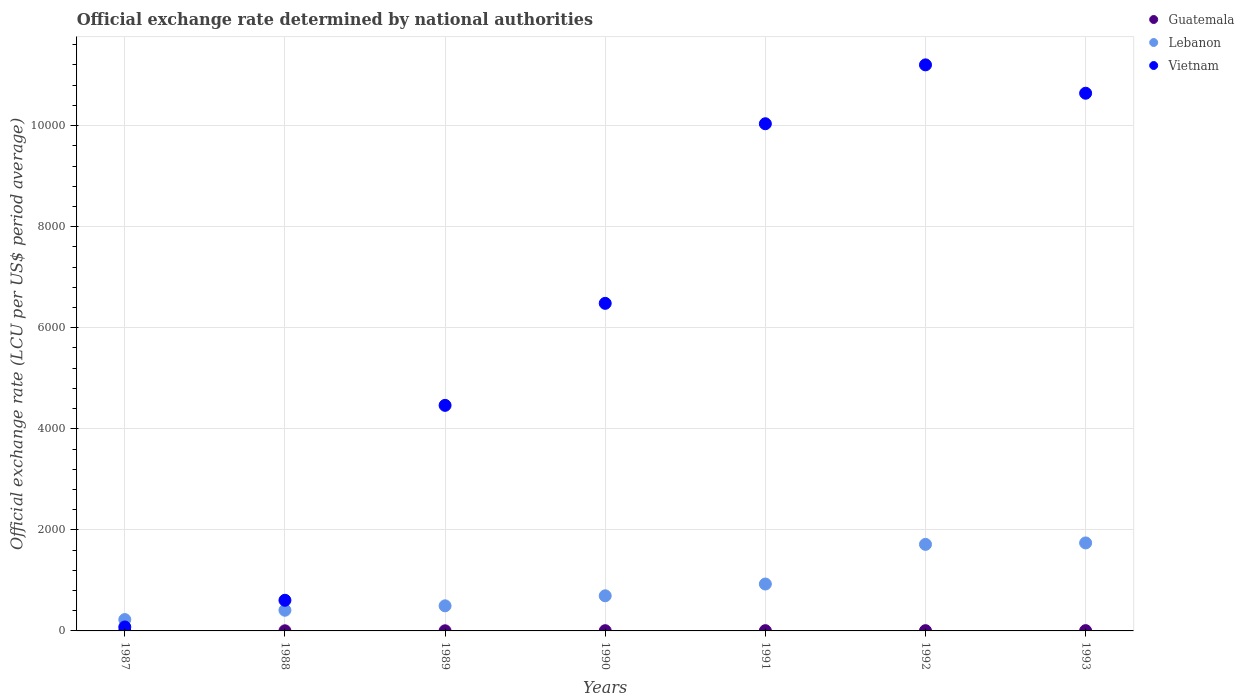How many different coloured dotlines are there?
Your response must be concise. 3. Is the number of dotlines equal to the number of legend labels?
Your answer should be compact. Yes. What is the official exchange rate in Guatemala in 1988?
Your response must be concise. 2.62. Across all years, what is the maximum official exchange rate in Guatemala?
Offer a terse response. 5.64. Across all years, what is the minimum official exchange rate in Guatemala?
Offer a terse response. 2.5. In which year was the official exchange rate in Lebanon maximum?
Your answer should be very brief. 1993. In which year was the official exchange rate in Lebanon minimum?
Ensure brevity in your answer.  1987. What is the total official exchange rate in Guatemala in the graph?
Provide a short and direct response. 28.26. What is the difference between the official exchange rate in Lebanon in 1988 and that in 1990?
Provide a succinct answer. -285.86. What is the difference between the official exchange rate in Vietnam in 1991 and the official exchange rate in Guatemala in 1989?
Keep it short and to the point. 1.00e+04. What is the average official exchange rate in Lebanon per year?
Give a very brief answer. 886.86. In the year 1988, what is the difference between the official exchange rate in Vietnam and official exchange rate in Guatemala?
Provide a short and direct response. 603.9. What is the ratio of the official exchange rate in Vietnam in 1987 to that in 1991?
Your answer should be compact. 0.01. Is the difference between the official exchange rate in Vietnam in 1988 and 1990 greater than the difference between the official exchange rate in Guatemala in 1988 and 1990?
Offer a terse response. No. What is the difference between the highest and the second highest official exchange rate in Vietnam?
Your response must be concise. 561.23. What is the difference between the highest and the lowest official exchange rate in Lebanon?
Give a very brief answer. 1516.77. In how many years, is the official exchange rate in Vietnam greater than the average official exchange rate in Vietnam taken over all years?
Offer a very short reply. 4. Does the official exchange rate in Lebanon monotonically increase over the years?
Provide a short and direct response. Yes. Is the official exchange rate in Vietnam strictly greater than the official exchange rate in Lebanon over the years?
Make the answer very short. No. Is the official exchange rate in Lebanon strictly less than the official exchange rate in Vietnam over the years?
Provide a succinct answer. No. How many dotlines are there?
Keep it short and to the point. 3. How many years are there in the graph?
Ensure brevity in your answer.  7. What is the difference between two consecutive major ticks on the Y-axis?
Offer a very short reply. 2000. Does the graph contain grids?
Give a very brief answer. Yes. Where does the legend appear in the graph?
Provide a short and direct response. Top right. How many legend labels are there?
Your response must be concise. 3. What is the title of the graph?
Your answer should be very brief. Official exchange rate determined by national authorities. Does "Uzbekistan" appear as one of the legend labels in the graph?
Your response must be concise. No. What is the label or title of the Y-axis?
Your answer should be compact. Official exchange rate (LCU per US$ period average). What is the Official exchange rate (LCU per US$ period average) in Guatemala in 1987?
Ensure brevity in your answer.  2.5. What is the Official exchange rate (LCU per US$ period average) in Lebanon in 1987?
Offer a very short reply. 224.6. What is the Official exchange rate (LCU per US$ period average) of Vietnam in 1987?
Keep it short and to the point. 78.29. What is the Official exchange rate (LCU per US$ period average) of Guatemala in 1988?
Your answer should be very brief. 2.62. What is the Official exchange rate (LCU per US$ period average) in Lebanon in 1988?
Give a very brief answer. 409.23. What is the Official exchange rate (LCU per US$ period average) of Vietnam in 1988?
Keep it short and to the point. 606.52. What is the Official exchange rate (LCU per US$ period average) of Guatemala in 1989?
Give a very brief answer. 2.82. What is the Official exchange rate (LCU per US$ period average) of Lebanon in 1989?
Your answer should be compact. 496.69. What is the Official exchange rate (LCU per US$ period average) in Vietnam in 1989?
Ensure brevity in your answer.  4463.95. What is the Official exchange rate (LCU per US$ period average) of Guatemala in 1990?
Your response must be concise. 4.49. What is the Official exchange rate (LCU per US$ period average) in Lebanon in 1990?
Your response must be concise. 695.09. What is the Official exchange rate (LCU per US$ period average) in Vietnam in 1990?
Ensure brevity in your answer.  6482.8. What is the Official exchange rate (LCU per US$ period average) of Guatemala in 1991?
Your response must be concise. 5.03. What is the Official exchange rate (LCU per US$ period average) of Lebanon in 1991?
Your answer should be very brief. 928.23. What is the Official exchange rate (LCU per US$ period average) in Vietnam in 1991?
Provide a succinct answer. 1.00e+04. What is the Official exchange rate (LCU per US$ period average) of Guatemala in 1992?
Provide a short and direct response. 5.17. What is the Official exchange rate (LCU per US$ period average) in Lebanon in 1992?
Offer a terse response. 1712.79. What is the Official exchange rate (LCU per US$ period average) in Vietnam in 1992?
Keep it short and to the point. 1.12e+04. What is the Official exchange rate (LCU per US$ period average) in Guatemala in 1993?
Offer a very short reply. 5.64. What is the Official exchange rate (LCU per US$ period average) of Lebanon in 1993?
Ensure brevity in your answer.  1741.36. What is the Official exchange rate (LCU per US$ period average) of Vietnam in 1993?
Make the answer very short. 1.06e+04. Across all years, what is the maximum Official exchange rate (LCU per US$ period average) in Guatemala?
Your answer should be compact. 5.64. Across all years, what is the maximum Official exchange rate (LCU per US$ period average) in Lebanon?
Offer a very short reply. 1741.36. Across all years, what is the maximum Official exchange rate (LCU per US$ period average) in Vietnam?
Offer a very short reply. 1.12e+04. Across all years, what is the minimum Official exchange rate (LCU per US$ period average) in Guatemala?
Keep it short and to the point. 2.5. Across all years, what is the minimum Official exchange rate (LCU per US$ period average) of Lebanon?
Give a very brief answer. 224.6. Across all years, what is the minimum Official exchange rate (LCU per US$ period average) of Vietnam?
Ensure brevity in your answer.  78.29. What is the total Official exchange rate (LCU per US$ period average) of Guatemala in the graph?
Offer a terse response. 28.26. What is the total Official exchange rate (LCU per US$ period average) in Lebanon in the graph?
Your answer should be compact. 6207.99. What is the total Official exchange rate (LCU per US$ period average) in Vietnam in the graph?
Keep it short and to the point. 4.35e+04. What is the difference between the Official exchange rate (LCU per US$ period average) in Guatemala in 1987 and that in 1988?
Your response must be concise. -0.12. What is the difference between the Official exchange rate (LCU per US$ period average) of Lebanon in 1987 and that in 1988?
Provide a succinct answer. -184.63. What is the difference between the Official exchange rate (LCU per US$ period average) in Vietnam in 1987 and that in 1988?
Provide a succinct answer. -528.23. What is the difference between the Official exchange rate (LCU per US$ period average) in Guatemala in 1987 and that in 1989?
Provide a succinct answer. -0.32. What is the difference between the Official exchange rate (LCU per US$ period average) in Lebanon in 1987 and that in 1989?
Offer a very short reply. -272.09. What is the difference between the Official exchange rate (LCU per US$ period average) in Vietnam in 1987 and that in 1989?
Your response must be concise. -4385.65. What is the difference between the Official exchange rate (LCU per US$ period average) in Guatemala in 1987 and that in 1990?
Provide a short and direct response. -1.99. What is the difference between the Official exchange rate (LCU per US$ period average) of Lebanon in 1987 and that in 1990?
Offer a very short reply. -470.49. What is the difference between the Official exchange rate (LCU per US$ period average) of Vietnam in 1987 and that in 1990?
Make the answer very short. -6404.5. What is the difference between the Official exchange rate (LCU per US$ period average) in Guatemala in 1987 and that in 1991?
Your answer should be compact. -2.53. What is the difference between the Official exchange rate (LCU per US$ period average) of Lebanon in 1987 and that in 1991?
Your response must be concise. -703.63. What is the difference between the Official exchange rate (LCU per US$ period average) of Vietnam in 1987 and that in 1991?
Ensure brevity in your answer.  -9958.74. What is the difference between the Official exchange rate (LCU per US$ period average) of Guatemala in 1987 and that in 1992?
Give a very brief answer. -2.67. What is the difference between the Official exchange rate (LCU per US$ period average) in Lebanon in 1987 and that in 1992?
Your answer should be compact. -1488.19. What is the difference between the Official exchange rate (LCU per US$ period average) of Vietnam in 1987 and that in 1992?
Provide a short and direct response. -1.11e+04. What is the difference between the Official exchange rate (LCU per US$ period average) in Guatemala in 1987 and that in 1993?
Give a very brief answer. -3.14. What is the difference between the Official exchange rate (LCU per US$ period average) in Lebanon in 1987 and that in 1993?
Your answer should be compact. -1516.77. What is the difference between the Official exchange rate (LCU per US$ period average) in Vietnam in 1987 and that in 1993?
Your answer should be compact. -1.06e+04. What is the difference between the Official exchange rate (LCU per US$ period average) of Guatemala in 1988 and that in 1989?
Ensure brevity in your answer.  -0.2. What is the difference between the Official exchange rate (LCU per US$ period average) in Lebanon in 1988 and that in 1989?
Keep it short and to the point. -87.46. What is the difference between the Official exchange rate (LCU per US$ period average) in Vietnam in 1988 and that in 1989?
Provide a short and direct response. -3857.43. What is the difference between the Official exchange rate (LCU per US$ period average) in Guatemala in 1988 and that in 1990?
Your answer should be very brief. -1.87. What is the difference between the Official exchange rate (LCU per US$ period average) of Lebanon in 1988 and that in 1990?
Give a very brief answer. -285.86. What is the difference between the Official exchange rate (LCU per US$ period average) of Vietnam in 1988 and that in 1990?
Make the answer very short. -5876.28. What is the difference between the Official exchange rate (LCU per US$ period average) of Guatemala in 1988 and that in 1991?
Keep it short and to the point. -2.41. What is the difference between the Official exchange rate (LCU per US$ period average) in Lebanon in 1988 and that in 1991?
Offer a terse response. -519. What is the difference between the Official exchange rate (LCU per US$ period average) in Vietnam in 1988 and that in 1991?
Provide a succinct answer. -9430.52. What is the difference between the Official exchange rate (LCU per US$ period average) in Guatemala in 1988 and that in 1992?
Your answer should be very brief. -2.55. What is the difference between the Official exchange rate (LCU per US$ period average) in Lebanon in 1988 and that in 1992?
Provide a succinct answer. -1303.56. What is the difference between the Official exchange rate (LCU per US$ period average) in Vietnam in 1988 and that in 1992?
Ensure brevity in your answer.  -1.06e+04. What is the difference between the Official exchange rate (LCU per US$ period average) of Guatemala in 1988 and that in 1993?
Offer a very short reply. -3.02. What is the difference between the Official exchange rate (LCU per US$ period average) in Lebanon in 1988 and that in 1993?
Provide a succinct answer. -1332.13. What is the difference between the Official exchange rate (LCU per US$ period average) in Vietnam in 1988 and that in 1993?
Your answer should be very brief. -1.00e+04. What is the difference between the Official exchange rate (LCU per US$ period average) of Guatemala in 1989 and that in 1990?
Offer a very short reply. -1.67. What is the difference between the Official exchange rate (LCU per US$ period average) of Lebanon in 1989 and that in 1990?
Provide a short and direct response. -198.4. What is the difference between the Official exchange rate (LCU per US$ period average) of Vietnam in 1989 and that in 1990?
Your answer should be very brief. -2018.85. What is the difference between the Official exchange rate (LCU per US$ period average) in Guatemala in 1989 and that in 1991?
Keep it short and to the point. -2.21. What is the difference between the Official exchange rate (LCU per US$ period average) of Lebanon in 1989 and that in 1991?
Give a very brief answer. -431.54. What is the difference between the Official exchange rate (LCU per US$ period average) in Vietnam in 1989 and that in 1991?
Ensure brevity in your answer.  -5573.09. What is the difference between the Official exchange rate (LCU per US$ period average) of Guatemala in 1989 and that in 1992?
Ensure brevity in your answer.  -2.35. What is the difference between the Official exchange rate (LCU per US$ period average) of Lebanon in 1989 and that in 1992?
Your response must be concise. -1216.1. What is the difference between the Official exchange rate (LCU per US$ period average) of Vietnam in 1989 and that in 1992?
Keep it short and to the point. -6738.25. What is the difference between the Official exchange rate (LCU per US$ period average) of Guatemala in 1989 and that in 1993?
Keep it short and to the point. -2.82. What is the difference between the Official exchange rate (LCU per US$ period average) in Lebanon in 1989 and that in 1993?
Your response must be concise. -1244.67. What is the difference between the Official exchange rate (LCU per US$ period average) of Vietnam in 1989 and that in 1993?
Keep it short and to the point. -6177.01. What is the difference between the Official exchange rate (LCU per US$ period average) in Guatemala in 1990 and that in 1991?
Give a very brief answer. -0.54. What is the difference between the Official exchange rate (LCU per US$ period average) of Lebanon in 1990 and that in 1991?
Offer a very short reply. -233.14. What is the difference between the Official exchange rate (LCU per US$ period average) of Vietnam in 1990 and that in 1991?
Offer a terse response. -3554.24. What is the difference between the Official exchange rate (LCU per US$ period average) of Guatemala in 1990 and that in 1992?
Provide a short and direct response. -0.68. What is the difference between the Official exchange rate (LCU per US$ period average) of Lebanon in 1990 and that in 1992?
Provide a succinct answer. -1017.7. What is the difference between the Official exchange rate (LCU per US$ period average) of Vietnam in 1990 and that in 1992?
Your answer should be compact. -4719.4. What is the difference between the Official exchange rate (LCU per US$ period average) of Guatemala in 1990 and that in 1993?
Ensure brevity in your answer.  -1.15. What is the difference between the Official exchange rate (LCU per US$ period average) of Lebanon in 1990 and that in 1993?
Provide a short and direct response. -1046.27. What is the difference between the Official exchange rate (LCU per US$ period average) of Vietnam in 1990 and that in 1993?
Offer a terse response. -4158.16. What is the difference between the Official exchange rate (LCU per US$ period average) of Guatemala in 1991 and that in 1992?
Give a very brief answer. -0.14. What is the difference between the Official exchange rate (LCU per US$ period average) of Lebanon in 1991 and that in 1992?
Your response must be concise. -784.56. What is the difference between the Official exchange rate (LCU per US$ period average) of Vietnam in 1991 and that in 1992?
Your answer should be very brief. -1165.16. What is the difference between the Official exchange rate (LCU per US$ period average) in Guatemala in 1991 and that in 1993?
Your answer should be very brief. -0.61. What is the difference between the Official exchange rate (LCU per US$ period average) of Lebanon in 1991 and that in 1993?
Offer a very short reply. -813.14. What is the difference between the Official exchange rate (LCU per US$ period average) of Vietnam in 1991 and that in 1993?
Ensure brevity in your answer.  -603.92. What is the difference between the Official exchange rate (LCU per US$ period average) in Guatemala in 1992 and that in 1993?
Make the answer very short. -0.46. What is the difference between the Official exchange rate (LCU per US$ period average) in Lebanon in 1992 and that in 1993?
Your answer should be compact. -28.57. What is the difference between the Official exchange rate (LCU per US$ period average) of Vietnam in 1992 and that in 1993?
Offer a terse response. 561.23. What is the difference between the Official exchange rate (LCU per US$ period average) of Guatemala in 1987 and the Official exchange rate (LCU per US$ period average) of Lebanon in 1988?
Give a very brief answer. -406.73. What is the difference between the Official exchange rate (LCU per US$ period average) in Guatemala in 1987 and the Official exchange rate (LCU per US$ period average) in Vietnam in 1988?
Keep it short and to the point. -604.02. What is the difference between the Official exchange rate (LCU per US$ period average) of Lebanon in 1987 and the Official exchange rate (LCU per US$ period average) of Vietnam in 1988?
Your answer should be compact. -381.92. What is the difference between the Official exchange rate (LCU per US$ period average) in Guatemala in 1987 and the Official exchange rate (LCU per US$ period average) in Lebanon in 1989?
Your answer should be compact. -494.19. What is the difference between the Official exchange rate (LCU per US$ period average) in Guatemala in 1987 and the Official exchange rate (LCU per US$ period average) in Vietnam in 1989?
Give a very brief answer. -4461.45. What is the difference between the Official exchange rate (LCU per US$ period average) of Lebanon in 1987 and the Official exchange rate (LCU per US$ period average) of Vietnam in 1989?
Provide a succinct answer. -4239.35. What is the difference between the Official exchange rate (LCU per US$ period average) of Guatemala in 1987 and the Official exchange rate (LCU per US$ period average) of Lebanon in 1990?
Your answer should be very brief. -692.59. What is the difference between the Official exchange rate (LCU per US$ period average) of Guatemala in 1987 and the Official exchange rate (LCU per US$ period average) of Vietnam in 1990?
Make the answer very short. -6480.3. What is the difference between the Official exchange rate (LCU per US$ period average) in Lebanon in 1987 and the Official exchange rate (LCU per US$ period average) in Vietnam in 1990?
Ensure brevity in your answer.  -6258.2. What is the difference between the Official exchange rate (LCU per US$ period average) in Guatemala in 1987 and the Official exchange rate (LCU per US$ period average) in Lebanon in 1991?
Give a very brief answer. -925.73. What is the difference between the Official exchange rate (LCU per US$ period average) of Guatemala in 1987 and the Official exchange rate (LCU per US$ period average) of Vietnam in 1991?
Your answer should be very brief. -1.00e+04. What is the difference between the Official exchange rate (LCU per US$ period average) of Lebanon in 1987 and the Official exchange rate (LCU per US$ period average) of Vietnam in 1991?
Keep it short and to the point. -9812.44. What is the difference between the Official exchange rate (LCU per US$ period average) in Guatemala in 1987 and the Official exchange rate (LCU per US$ period average) in Lebanon in 1992?
Keep it short and to the point. -1710.29. What is the difference between the Official exchange rate (LCU per US$ period average) of Guatemala in 1987 and the Official exchange rate (LCU per US$ period average) of Vietnam in 1992?
Your response must be concise. -1.12e+04. What is the difference between the Official exchange rate (LCU per US$ period average) of Lebanon in 1987 and the Official exchange rate (LCU per US$ period average) of Vietnam in 1992?
Your answer should be compact. -1.10e+04. What is the difference between the Official exchange rate (LCU per US$ period average) in Guatemala in 1987 and the Official exchange rate (LCU per US$ period average) in Lebanon in 1993?
Provide a succinct answer. -1738.86. What is the difference between the Official exchange rate (LCU per US$ period average) of Guatemala in 1987 and the Official exchange rate (LCU per US$ period average) of Vietnam in 1993?
Offer a terse response. -1.06e+04. What is the difference between the Official exchange rate (LCU per US$ period average) in Lebanon in 1987 and the Official exchange rate (LCU per US$ period average) in Vietnam in 1993?
Keep it short and to the point. -1.04e+04. What is the difference between the Official exchange rate (LCU per US$ period average) in Guatemala in 1988 and the Official exchange rate (LCU per US$ period average) in Lebanon in 1989?
Offer a terse response. -494.07. What is the difference between the Official exchange rate (LCU per US$ period average) of Guatemala in 1988 and the Official exchange rate (LCU per US$ period average) of Vietnam in 1989?
Your answer should be very brief. -4461.33. What is the difference between the Official exchange rate (LCU per US$ period average) in Lebanon in 1988 and the Official exchange rate (LCU per US$ period average) in Vietnam in 1989?
Provide a short and direct response. -4054.72. What is the difference between the Official exchange rate (LCU per US$ period average) of Guatemala in 1988 and the Official exchange rate (LCU per US$ period average) of Lebanon in 1990?
Ensure brevity in your answer.  -692.47. What is the difference between the Official exchange rate (LCU per US$ period average) in Guatemala in 1988 and the Official exchange rate (LCU per US$ period average) in Vietnam in 1990?
Offer a very short reply. -6480.18. What is the difference between the Official exchange rate (LCU per US$ period average) in Lebanon in 1988 and the Official exchange rate (LCU per US$ period average) in Vietnam in 1990?
Your answer should be compact. -6073.57. What is the difference between the Official exchange rate (LCU per US$ period average) of Guatemala in 1988 and the Official exchange rate (LCU per US$ period average) of Lebanon in 1991?
Give a very brief answer. -925.61. What is the difference between the Official exchange rate (LCU per US$ period average) of Guatemala in 1988 and the Official exchange rate (LCU per US$ period average) of Vietnam in 1991?
Your answer should be very brief. -1.00e+04. What is the difference between the Official exchange rate (LCU per US$ period average) in Lebanon in 1988 and the Official exchange rate (LCU per US$ period average) in Vietnam in 1991?
Offer a very short reply. -9627.8. What is the difference between the Official exchange rate (LCU per US$ period average) of Guatemala in 1988 and the Official exchange rate (LCU per US$ period average) of Lebanon in 1992?
Your answer should be compact. -1710.17. What is the difference between the Official exchange rate (LCU per US$ period average) of Guatemala in 1988 and the Official exchange rate (LCU per US$ period average) of Vietnam in 1992?
Make the answer very short. -1.12e+04. What is the difference between the Official exchange rate (LCU per US$ period average) of Lebanon in 1988 and the Official exchange rate (LCU per US$ period average) of Vietnam in 1992?
Your answer should be compact. -1.08e+04. What is the difference between the Official exchange rate (LCU per US$ period average) of Guatemala in 1988 and the Official exchange rate (LCU per US$ period average) of Lebanon in 1993?
Ensure brevity in your answer.  -1738.74. What is the difference between the Official exchange rate (LCU per US$ period average) in Guatemala in 1988 and the Official exchange rate (LCU per US$ period average) in Vietnam in 1993?
Keep it short and to the point. -1.06e+04. What is the difference between the Official exchange rate (LCU per US$ period average) in Lebanon in 1988 and the Official exchange rate (LCU per US$ period average) in Vietnam in 1993?
Keep it short and to the point. -1.02e+04. What is the difference between the Official exchange rate (LCU per US$ period average) of Guatemala in 1989 and the Official exchange rate (LCU per US$ period average) of Lebanon in 1990?
Provide a short and direct response. -692.27. What is the difference between the Official exchange rate (LCU per US$ period average) in Guatemala in 1989 and the Official exchange rate (LCU per US$ period average) in Vietnam in 1990?
Ensure brevity in your answer.  -6479.98. What is the difference between the Official exchange rate (LCU per US$ period average) of Lebanon in 1989 and the Official exchange rate (LCU per US$ period average) of Vietnam in 1990?
Your answer should be compact. -5986.11. What is the difference between the Official exchange rate (LCU per US$ period average) in Guatemala in 1989 and the Official exchange rate (LCU per US$ period average) in Lebanon in 1991?
Provide a succinct answer. -925.41. What is the difference between the Official exchange rate (LCU per US$ period average) in Guatemala in 1989 and the Official exchange rate (LCU per US$ period average) in Vietnam in 1991?
Give a very brief answer. -1.00e+04. What is the difference between the Official exchange rate (LCU per US$ period average) of Lebanon in 1989 and the Official exchange rate (LCU per US$ period average) of Vietnam in 1991?
Offer a terse response. -9540.35. What is the difference between the Official exchange rate (LCU per US$ period average) in Guatemala in 1989 and the Official exchange rate (LCU per US$ period average) in Lebanon in 1992?
Your answer should be very brief. -1709.97. What is the difference between the Official exchange rate (LCU per US$ period average) in Guatemala in 1989 and the Official exchange rate (LCU per US$ period average) in Vietnam in 1992?
Offer a terse response. -1.12e+04. What is the difference between the Official exchange rate (LCU per US$ period average) of Lebanon in 1989 and the Official exchange rate (LCU per US$ period average) of Vietnam in 1992?
Your answer should be compact. -1.07e+04. What is the difference between the Official exchange rate (LCU per US$ period average) of Guatemala in 1989 and the Official exchange rate (LCU per US$ period average) of Lebanon in 1993?
Ensure brevity in your answer.  -1738.55. What is the difference between the Official exchange rate (LCU per US$ period average) in Guatemala in 1989 and the Official exchange rate (LCU per US$ period average) in Vietnam in 1993?
Provide a succinct answer. -1.06e+04. What is the difference between the Official exchange rate (LCU per US$ period average) of Lebanon in 1989 and the Official exchange rate (LCU per US$ period average) of Vietnam in 1993?
Your answer should be very brief. -1.01e+04. What is the difference between the Official exchange rate (LCU per US$ period average) of Guatemala in 1990 and the Official exchange rate (LCU per US$ period average) of Lebanon in 1991?
Make the answer very short. -923.74. What is the difference between the Official exchange rate (LCU per US$ period average) of Guatemala in 1990 and the Official exchange rate (LCU per US$ period average) of Vietnam in 1991?
Provide a short and direct response. -1.00e+04. What is the difference between the Official exchange rate (LCU per US$ period average) in Lebanon in 1990 and the Official exchange rate (LCU per US$ period average) in Vietnam in 1991?
Offer a terse response. -9341.95. What is the difference between the Official exchange rate (LCU per US$ period average) in Guatemala in 1990 and the Official exchange rate (LCU per US$ period average) in Lebanon in 1992?
Offer a very short reply. -1708.31. What is the difference between the Official exchange rate (LCU per US$ period average) in Guatemala in 1990 and the Official exchange rate (LCU per US$ period average) in Vietnam in 1992?
Offer a very short reply. -1.12e+04. What is the difference between the Official exchange rate (LCU per US$ period average) of Lebanon in 1990 and the Official exchange rate (LCU per US$ period average) of Vietnam in 1992?
Your response must be concise. -1.05e+04. What is the difference between the Official exchange rate (LCU per US$ period average) in Guatemala in 1990 and the Official exchange rate (LCU per US$ period average) in Lebanon in 1993?
Your answer should be compact. -1736.88. What is the difference between the Official exchange rate (LCU per US$ period average) in Guatemala in 1990 and the Official exchange rate (LCU per US$ period average) in Vietnam in 1993?
Provide a short and direct response. -1.06e+04. What is the difference between the Official exchange rate (LCU per US$ period average) of Lebanon in 1990 and the Official exchange rate (LCU per US$ period average) of Vietnam in 1993?
Your answer should be compact. -9945.87. What is the difference between the Official exchange rate (LCU per US$ period average) of Guatemala in 1991 and the Official exchange rate (LCU per US$ period average) of Lebanon in 1992?
Your answer should be very brief. -1707.76. What is the difference between the Official exchange rate (LCU per US$ period average) in Guatemala in 1991 and the Official exchange rate (LCU per US$ period average) in Vietnam in 1992?
Your answer should be very brief. -1.12e+04. What is the difference between the Official exchange rate (LCU per US$ period average) in Lebanon in 1991 and the Official exchange rate (LCU per US$ period average) in Vietnam in 1992?
Keep it short and to the point. -1.03e+04. What is the difference between the Official exchange rate (LCU per US$ period average) of Guatemala in 1991 and the Official exchange rate (LCU per US$ period average) of Lebanon in 1993?
Offer a very short reply. -1736.33. What is the difference between the Official exchange rate (LCU per US$ period average) of Guatemala in 1991 and the Official exchange rate (LCU per US$ period average) of Vietnam in 1993?
Provide a succinct answer. -1.06e+04. What is the difference between the Official exchange rate (LCU per US$ period average) of Lebanon in 1991 and the Official exchange rate (LCU per US$ period average) of Vietnam in 1993?
Your answer should be compact. -9712.73. What is the difference between the Official exchange rate (LCU per US$ period average) in Guatemala in 1992 and the Official exchange rate (LCU per US$ period average) in Lebanon in 1993?
Offer a terse response. -1736.19. What is the difference between the Official exchange rate (LCU per US$ period average) of Guatemala in 1992 and the Official exchange rate (LCU per US$ period average) of Vietnam in 1993?
Offer a very short reply. -1.06e+04. What is the difference between the Official exchange rate (LCU per US$ period average) in Lebanon in 1992 and the Official exchange rate (LCU per US$ period average) in Vietnam in 1993?
Provide a succinct answer. -8928.17. What is the average Official exchange rate (LCU per US$ period average) in Guatemala per year?
Your answer should be compact. 4.04. What is the average Official exchange rate (LCU per US$ period average) of Lebanon per year?
Your answer should be compact. 886.86. What is the average Official exchange rate (LCU per US$ period average) in Vietnam per year?
Make the answer very short. 6215.96. In the year 1987, what is the difference between the Official exchange rate (LCU per US$ period average) of Guatemala and Official exchange rate (LCU per US$ period average) of Lebanon?
Keep it short and to the point. -222.1. In the year 1987, what is the difference between the Official exchange rate (LCU per US$ period average) of Guatemala and Official exchange rate (LCU per US$ period average) of Vietnam?
Your answer should be very brief. -75.79. In the year 1987, what is the difference between the Official exchange rate (LCU per US$ period average) of Lebanon and Official exchange rate (LCU per US$ period average) of Vietnam?
Provide a short and direct response. 146.3. In the year 1988, what is the difference between the Official exchange rate (LCU per US$ period average) in Guatemala and Official exchange rate (LCU per US$ period average) in Lebanon?
Your answer should be very brief. -406.61. In the year 1988, what is the difference between the Official exchange rate (LCU per US$ period average) in Guatemala and Official exchange rate (LCU per US$ period average) in Vietnam?
Keep it short and to the point. -603.9. In the year 1988, what is the difference between the Official exchange rate (LCU per US$ period average) of Lebanon and Official exchange rate (LCU per US$ period average) of Vietnam?
Your answer should be compact. -197.29. In the year 1989, what is the difference between the Official exchange rate (LCU per US$ period average) of Guatemala and Official exchange rate (LCU per US$ period average) of Lebanon?
Keep it short and to the point. -493.87. In the year 1989, what is the difference between the Official exchange rate (LCU per US$ period average) of Guatemala and Official exchange rate (LCU per US$ period average) of Vietnam?
Make the answer very short. -4461.13. In the year 1989, what is the difference between the Official exchange rate (LCU per US$ period average) in Lebanon and Official exchange rate (LCU per US$ period average) in Vietnam?
Make the answer very short. -3967.26. In the year 1990, what is the difference between the Official exchange rate (LCU per US$ period average) in Guatemala and Official exchange rate (LCU per US$ period average) in Lebanon?
Ensure brevity in your answer.  -690.6. In the year 1990, what is the difference between the Official exchange rate (LCU per US$ period average) of Guatemala and Official exchange rate (LCU per US$ period average) of Vietnam?
Ensure brevity in your answer.  -6478.31. In the year 1990, what is the difference between the Official exchange rate (LCU per US$ period average) in Lebanon and Official exchange rate (LCU per US$ period average) in Vietnam?
Keep it short and to the point. -5787.71. In the year 1991, what is the difference between the Official exchange rate (LCU per US$ period average) of Guatemala and Official exchange rate (LCU per US$ period average) of Lebanon?
Offer a very short reply. -923.2. In the year 1991, what is the difference between the Official exchange rate (LCU per US$ period average) in Guatemala and Official exchange rate (LCU per US$ period average) in Vietnam?
Offer a very short reply. -1.00e+04. In the year 1991, what is the difference between the Official exchange rate (LCU per US$ period average) of Lebanon and Official exchange rate (LCU per US$ period average) of Vietnam?
Provide a succinct answer. -9108.81. In the year 1992, what is the difference between the Official exchange rate (LCU per US$ period average) in Guatemala and Official exchange rate (LCU per US$ period average) in Lebanon?
Ensure brevity in your answer.  -1707.62. In the year 1992, what is the difference between the Official exchange rate (LCU per US$ period average) of Guatemala and Official exchange rate (LCU per US$ period average) of Vietnam?
Your answer should be very brief. -1.12e+04. In the year 1992, what is the difference between the Official exchange rate (LCU per US$ period average) in Lebanon and Official exchange rate (LCU per US$ period average) in Vietnam?
Provide a succinct answer. -9489.4. In the year 1993, what is the difference between the Official exchange rate (LCU per US$ period average) in Guatemala and Official exchange rate (LCU per US$ period average) in Lebanon?
Your response must be concise. -1735.73. In the year 1993, what is the difference between the Official exchange rate (LCU per US$ period average) in Guatemala and Official exchange rate (LCU per US$ period average) in Vietnam?
Your answer should be compact. -1.06e+04. In the year 1993, what is the difference between the Official exchange rate (LCU per US$ period average) in Lebanon and Official exchange rate (LCU per US$ period average) in Vietnam?
Your answer should be compact. -8899.59. What is the ratio of the Official exchange rate (LCU per US$ period average) in Guatemala in 1987 to that in 1988?
Make the answer very short. 0.95. What is the ratio of the Official exchange rate (LCU per US$ period average) of Lebanon in 1987 to that in 1988?
Give a very brief answer. 0.55. What is the ratio of the Official exchange rate (LCU per US$ period average) in Vietnam in 1987 to that in 1988?
Provide a short and direct response. 0.13. What is the ratio of the Official exchange rate (LCU per US$ period average) of Guatemala in 1987 to that in 1989?
Ensure brevity in your answer.  0.89. What is the ratio of the Official exchange rate (LCU per US$ period average) in Lebanon in 1987 to that in 1989?
Keep it short and to the point. 0.45. What is the ratio of the Official exchange rate (LCU per US$ period average) in Vietnam in 1987 to that in 1989?
Your answer should be very brief. 0.02. What is the ratio of the Official exchange rate (LCU per US$ period average) in Guatemala in 1987 to that in 1990?
Offer a very short reply. 0.56. What is the ratio of the Official exchange rate (LCU per US$ period average) in Lebanon in 1987 to that in 1990?
Your answer should be very brief. 0.32. What is the ratio of the Official exchange rate (LCU per US$ period average) of Vietnam in 1987 to that in 1990?
Ensure brevity in your answer.  0.01. What is the ratio of the Official exchange rate (LCU per US$ period average) in Guatemala in 1987 to that in 1991?
Keep it short and to the point. 0.5. What is the ratio of the Official exchange rate (LCU per US$ period average) of Lebanon in 1987 to that in 1991?
Offer a terse response. 0.24. What is the ratio of the Official exchange rate (LCU per US$ period average) of Vietnam in 1987 to that in 1991?
Your answer should be compact. 0.01. What is the ratio of the Official exchange rate (LCU per US$ period average) in Guatemala in 1987 to that in 1992?
Provide a succinct answer. 0.48. What is the ratio of the Official exchange rate (LCU per US$ period average) of Lebanon in 1987 to that in 1992?
Provide a short and direct response. 0.13. What is the ratio of the Official exchange rate (LCU per US$ period average) of Vietnam in 1987 to that in 1992?
Your answer should be very brief. 0.01. What is the ratio of the Official exchange rate (LCU per US$ period average) in Guatemala in 1987 to that in 1993?
Your answer should be very brief. 0.44. What is the ratio of the Official exchange rate (LCU per US$ period average) of Lebanon in 1987 to that in 1993?
Your response must be concise. 0.13. What is the ratio of the Official exchange rate (LCU per US$ period average) of Vietnam in 1987 to that in 1993?
Ensure brevity in your answer.  0.01. What is the ratio of the Official exchange rate (LCU per US$ period average) in Guatemala in 1988 to that in 1989?
Make the answer very short. 0.93. What is the ratio of the Official exchange rate (LCU per US$ period average) in Lebanon in 1988 to that in 1989?
Offer a very short reply. 0.82. What is the ratio of the Official exchange rate (LCU per US$ period average) in Vietnam in 1988 to that in 1989?
Your answer should be very brief. 0.14. What is the ratio of the Official exchange rate (LCU per US$ period average) of Guatemala in 1988 to that in 1990?
Ensure brevity in your answer.  0.58. What is the ratio of the Official exchange rate (LCU per US$ period average) in Lebanon in 1988 to that in 1990?
Ensure brevity in your answer.  0.59. What is the ratio of the Official exchange rate (LCU per US$ period average) in Vietnam in 1988 to that in 1990?
Your response must be concise. 0.09. What is the ratio of the Official exchange rate (LCU per US$ period average) in Guatemala in 1988 to that in 1991?
Offer a very short reply. 0.52. What is the ratio of the Official exchange rate (LCU per US$ period average) in Lebanon in 1988 to that in 1991?
Offer a very short reply. 0.44. What is the ratio of the Official exchange rate (LCU per US$ period average) of Vietnam in 1988 to that in 1991?
Your answer should be compact. 0.06. What is the ratio of the Official exchange rate (LCU per US$ period average) of Guatemala in 1988 to that in 1992?
Keep it short and to the point. 0.51. What is the ratio of the Official exchange rate (LCU per US$ period average) of Lebanon in 1988 to that in 1992?
Provide a succinct answer. 0.24. What is the ratio of the Official exchange rate (LCU per US$ period average) in Vietnam in 1988 to that in 1992?
Keep it short and to the point. 0.05. What is the ratio of the Official exchange rate (LCU per US$ period average) of Guatemala in 1988 to that in 1993?
Your response must be concise. 0.46. What is the ratio of the Official exchange rate (LCU per US$ period average) of Lebanon in 1988 to that in 1993?
Your answer should be very brief. 0.23. What is the ratio of the Official exchange rate (LCU per US$ period average) in Vietnam in 1988 to that in 1993?
Provide a succinct answer. 0.06. What is the ratio of the Official exchange rate (LCU per US$ period average) of Guatemala in 1989 to that in 1990?
Your answer should be very brief. 0.63. What is the ratio of the Official exchange rate (LCU per US$ period average) in Lebanon in 1989 to that in 1990?
Make the answer very short. 0.71. What is the ratio of the Official exchange rate (LCU per US$ period average) of Vietnam in 1989 to that in 1990?
Keep it short and to the point. 0.69. What is the ratio of the Official exchange rate (LCU per US$ period average) in Guatemala in 1989 to that in 1991?
Offer a very short reply. 0.56. What is the ratio of the Official exchange rate (LCU per US$ period average) in Lebanon in 1989 to that in 1991?
Keep it short and to the point. 0.54. What is the ratio of the Official exchange rate (LCU per US$ period average) of Vietnam in 1989 to that in 1991?
Give a very brief answer. 0.44. What is the ratio of the Official exchange rate (LCU per US$ period average) in Guatemala in 1989 to that in 1992?
Your answer should be compact. 0.54. What is the ratio of the Official exchange rate (LCU per US$ period average) of Lebanon in 1989 to that in 1992?
Make the answer very short. 0.29. What is the ratio of the Official exchange rate (LCU per US$ period average) of Vietnam in 1989 to that in 1992?
Offer a very short reply. 0.4. What is the ratio of the Official exchange rate (LCU per US$ period average) of Guatemala in 1989 to that in 1993?
Offer a terse response. 0.5. What is the ratio of the Official exchange rate (LCU per US$ period average) of Lebanon in 1989 to that in 1993?
Offer a terse response. 0.29. What is the ratio of the Official exchange rate (LCU per US$ period average) of Vietnam in 1989 to that in 1993?
Provide a succinct answer. 0.42. What is the ratio of the Official exchange rate (LCU per US$ period average) of Guatemala in 1990 to that in 1991?
Offer a terse response. 0.89. What is the ratio of the Official exchange rate (LCU per US$ period average) in Lebanon in 1990 to that in 1991?
Your response must be concise. 0.75. What is the ratio of the Official exchange rate (LCU per US$ period average) of Vietnam in 1990 to that in 1991?
Ensure brevity in your answer.  0.65. What is the ratio of the Official exchange rate (LCU per US$ period average) of Guatemala in 1990 to that in 1992?
Keep it short and to the point. 0.87. What is the ratio of the Official exchange rate (LCU per US$ period average) in Lebanon in 1990 to that in 1992?
Give a very brief answer. 0.41. What is the ratio of the Official exchange rate (LCU per US$ period average) of Vietnam in 1990 to that in 1992?
Provide a succinct answer. 0.58. What is the ratio of the Official exchange rate (LCU per US$ period average) of Guatemala in 1990 to that in 1993?
Offer a terse response. 0.8. What is the ratio of the Official exchange rate (LCU per US$ period average) of Lebanon in 1990 to that in 1993?
Offer a terse response. 0.4. What is the ratio of the Official exchange rate (LCU per US$ period average) of Vietnam in 1990 to that in 1993?
Provide a short and direct response. 0.61. What is the ratio of the Official exchange rate (LCU per US$ period average) of Guatemala in 1991 to that in 1992?
Give a very brief answer. 0.97. What is the ratio of the Official exchange rate (LCU per US$ period average) of Lebanon in 1991 to that in 1992?
Ensure brevity in your answer.  0.54. What is the ratio of the Official exchange rate (LCU per US$ period average) of Vietnam in 1991 to that in 1992?
Offer a terse response. 0.9. What is the ratio of the Official exchange rate (LCU per US$ period average) of Guatemala in 1991 to that in 1993?
Provide a succinct answer. 0.89. What is the ratio of the Official exchange rate (LCU per US$ period average) of Lebanon in 1991 to that in 1993?
Provide a succinct answer. 0.53. What is the ratio of the Official exchange rate (LCU per US$ period average) in Vietnam in 1991 to that in 1993?
Make the answer very short. 0.94. What is the ratio of the Official exchange rate (LCU per US$ period average) in Guatemala in 1992 to that in 1993?
Give a very brief answer. 0.92. What is the ratio of the Official exchange rate (LCU per US$ period average) in Lebanon in 1992 to that in 1993?
Your answer should be very brief. 0.98. What is the ratio of the Official exchange rate (LCU per US$ period average) of Vietnam in 1992 to that in 1993?
Offer a very short reply. 1.05. What is the difference between the highest and the second highest Official exchange rate (LCU per US$ period average) of Guatemala?
Offer a terse response. 0.46. What is the difference between the highest and the second highest Official exchange rate (LCU per US$ period average) of Lebanon?
Ensure brevity in your answer.  28.57. What is the difference between the highest and the second highest Official exchange rate (LCU per US$ period average) in Vietnam?
Make the answer very short. 561.23. What is the difference between the highest and the lowest Official exchange rate (LCU per US$ period average) of Guatemala?
Keep it short and to the point. 3.14. What is the difference between the highest and the lowest Official exchange rate (LCU per US$ period average) of Lebanon?
Provide a succinct answer. 1516.77. What is the difference between the highest and the lowest Official exchange rate (LCU per US$ period average) of Vietnam?
Give a very brief answer. 1.11e+04. 